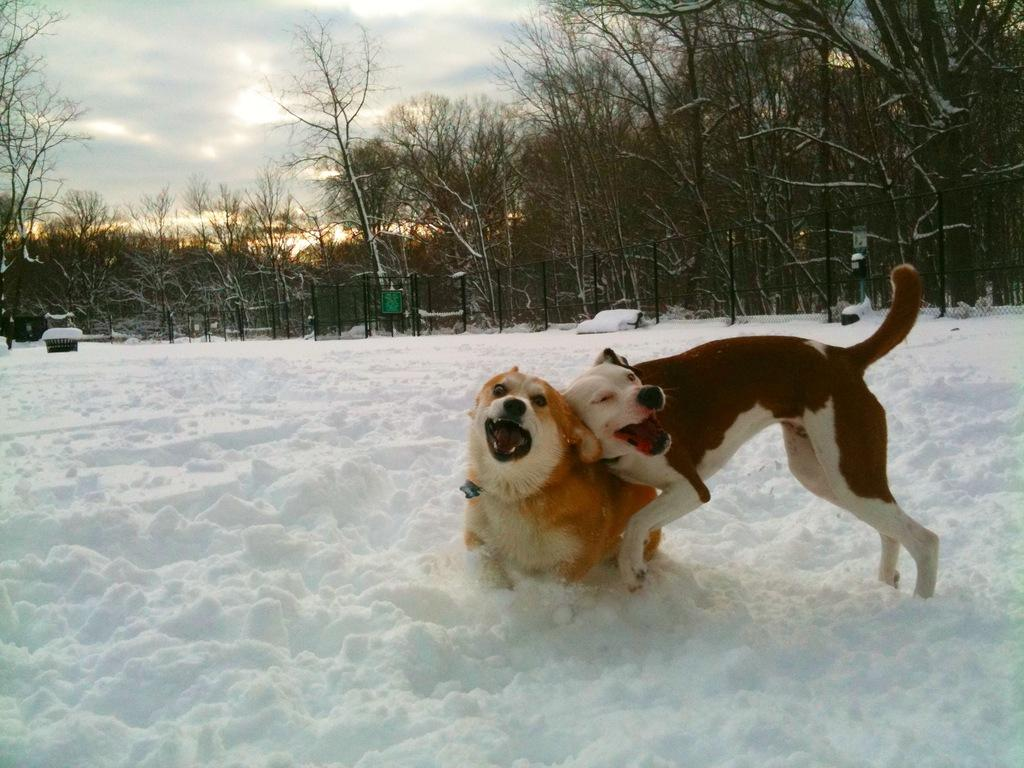What animals are present in the image? There are dogs in the image. Where are the dogs located? The dogs are in the snow. What can be seen in the background of the image? There are trees and clouds in the sky in the background of the image. What type of adjustment can be seen on the van in the image? There is no van present in the image; it features dogs in the snow with trees and clouds in the background. 